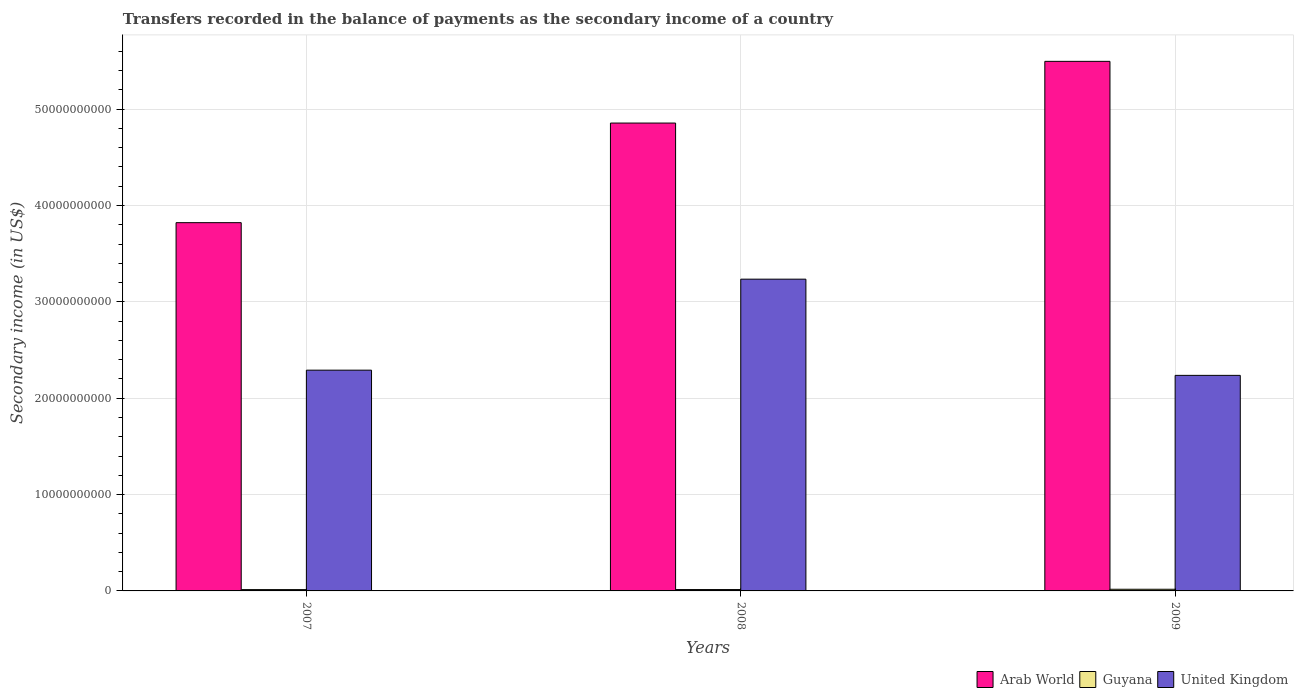How many different coloured bars are there?
Keep it short and to the point. 3. How many groups of bars are there?
Ensure brevity in your answer.  3. Are the number of bars per tick equal to the number of legend labels?
Your answer should be very brief. Yes. Are the number of bars on each tick of the X-axis equal?
Ensure brevity in your answer.  Yes. What is the secondary income of in Guyana in 2008?
Your answer should be very brief. 1.41e+08. Across all years, what is the maximum secondary income of in Guyana?
Provide a succinct answer. 1.72e+08. Across all years, what is the minimum secondary income of in Guyana?
Keep it short and to the point. 1.37e+08. In which year was the secondary income of in Arab World maximum?
Keep it short and to the point. 2009. What is the total secondary income of in Arab World in the graph?
Provide a short and direct response. 1.42e+11. What is the difference between the secondary income of in Arab World in 2007 and that in 2008?
Offer a very short reply. -1.03e+1. What is the difference between the secondary income of in Arab World in 2007 and the secondary income of in United Kingdom in 2009?
Offer a terse response. 1.58e+1. What is the average secondary income of in United Kingdom per year?
Ensure brevity in your answer.  2.59e+1. In the year 2009, what is the difference between the secondary income of in United Kingdom and secondary income of in Guyana?
Provide a succinct answer. 2.22e+1. What is the ratio of the secondary income of in United Kingdom in 2007 to that in 2009?
Offer a very short reply. 1.02. Is the difference between the secondary income of in United Kingdom in 2008 and 2009 greater than the difference between the secondary income of in Guyana in 2008 and 2009?
Provide a succinct answer. Yes. What is the difference between the highest and the second highest secondary income of in Guyana?
Provide a short and direct response. 3.10e+07. What is the difference between the highest and the lowest secondary income of in United Kingdom?
Provide a succinct answer. 9.98e+09. What does the 2nd bar from the left in 2009 represents?
Give a very brief answer. Guyana. What does the 2nd bar from the right in 2008 represents?
Keep it short and to the point. Guyana. Is it the case that in every year, the sum of the secondary income of in United Kingdom and secondary income of in Arab World is greater than the secondary income of in Guyana?
Your answer should be very brief. Yes. How many bars are there?
Provide a short and direct response. 9. Are all the bars in the graph horizontal?
Your answer should be very brief. No. What is the difference between two consecutive major ticks on the Y-axis?
Keep it short and to the point. 1.00e+1. Does the graph contain grids?
Ensure brevity in your answer.  Yes. How are the legend labels stacked?
Offer a terse response. Horizontal. What is the title of the graph?
Ensure brevity in your answer.  Transfers recorded in the balance of payments as the secondary income of a country. What is the label or title of the X-axis?
Your response must be concise. Years. What is the label or title of the Y-axis?
Your answer should be very brief. Secondary income (in US$). What is the Secondary income (in US$) of Arab World in 2007?
Ensure brevity in your answer.  3.82e+1. What is the Secondary income (in US$) of Guyana in 2007?
Give a very brief answer. 1.37e+08. What is the Secondary income (in US$) of United Kingdom in 2007?
Your response must be concise. 2.29e+1. What is the Secondary income (in US$) of Arab World in 2008?
Make the answer very short. 4.86e+1. What is the Secondary income (in US$) in Guyana in 2008?
Provide a short and direct response. 1.41e+08. What is the Secondary income (in US$) of United Kingdom in 2008?
Make the answer very short. 3.24e+1. What is the Secondary income (in US$) in Arab World in 2009?
Make the answer very short. 5.50e+1. What is the Secondary income (in US$) in Guyana in 2009?
Offer a terse response. 1.72e+08. What is the Secondary income (in US$) of United Kingdom in 2009?
Your answer should be compact. 2.24e+1. Across all years, what is the maximum Secondary income (in US$) of Arab World?
Provide a succinct answer. 5.50e+1. Across all years, what is the maximum Secondary income (in US$) of Guyana?
Give a very brief answer. 1.72e+08. Across all years, what is the maximum Secondary income (in US$) in United Kingdom?
Make the answer very short. 3.24e+1. Across all years, what is the minimum Secondary income (in US$) of Arab World?
Your answer should be very brief. 3.82e+1. Across all years, what is the minimum Secondary income (in US$) of Guyana?
Your response must be concise. 1.37e+08. Across all years, what is the minimum Secondary income (in US$) in United Kingdom?
Your answer should be very brief. 2.24e+1. What is the total Secondary income (in US$) in Arab World in the graph?
Ensure brevity in your answer.  1.42e+11. What is the total Secondary income (in US$) in Guyana in the graph?
Offer a terse response. 4.50e+08. What is the total Secondary income (in US$) in United Kingdom in the graph?
Make the answer very short. 7.76e+1. What is the difference between the Secondary income (in US$) of Arab World in 2007 and that in 2008?
Ensure brevity in your answer.  -1.03e+1. What is the difference between the Secondary income (in US$) of Guyana in 2007 and that in 2008?
Keep it short and to the point. -4.12e+06. What is the difference between the Secondary income (in US$) in United Kingdom in 2007 and that in 2008?
Offer a terse response. -9.44e+09. What is the difference between the Secondary income (in US$) of Arab World in 2007 and that in 2009?
Provide a succinct answer. -1.67e+1. What is the difference between the Secondary income (in US$) in Guyana in 2007 and that in 2009?
Make the answer very short. -3.51e+07. What is the difference between the Secondary income (in US$) of United Kingdom in 2007 and that in 2009?
Offer a very short reply. 5.41e+08. What is the difference between the Secondary income (in US$) of Arab World in 2008 and that in 2009?
Your response must be concise. -6.40e+09. What is the difference between the Secondary income (in US$) in Guyana in 2008 and that in 2009?
Keep it short and to the point. -3.10e+07. What is the difference between the Secondary income (in US$) of United Kingdom in 2008 and that in 2009?
Make the answer very short. 9.98e+09. What is the difference between the Secondary income (in US$) in Arab World in 2007 and the Secondary income (in US$) in Guyana in 2008?
Provide a succinct answer. 3.81e+1. What is the difference between the Secondary income (in US$) in Arab World in 2007 and the Secondary income (in US$) in United Kingdom in 2008?
Make the answer very short. 5.86e+09. What is the difference between the Secondary income (in US$) in Guyana in 2007 and the Secondary income (in US$) in United Kingdom in 2008?
Offer a very short reply. -3.22e+1. What is the difference between the Secondary income (in US$) in Arab World in 2007 and the Secondary income (in US$) in Guyana in 2009?
Offer a terse response. 3.80e+1. What is the difference between the Secondary income (in US$) of Arab World in 2007 and the Secondary income (in US$) of United Kingdom in 2009?
Give a very brief answer. 1.58e+1. What is the difference between the Secondary income (in US$) of Guyana in 2007 and the Secondary income (in US$) of United Kingdom in 2009?
Keep it short and to the point. -2.22e+1. What is the difference between the Secondary income (in US$) in Arab World in 2008 and the Secondary income (in US$) in Guyana in 2009?
Provide a succinct answer. 4.84e+1. What is the difference between the Secondary income (in US$) in Arab World in 2008 and the Secondary income (in US$) in United Kingdom in 2009?
Your answer should be very brief. 2.62e+1. What is the difference between the Secondary income (in US$) in Guyana in 2008 and the Secondary income (in US$) in United Kingdom in 2009?
Give a very brief answer. -2.22e+1. What is the average Secondary income (in US$) in Arab World per year?
Ensure brevity in your answer.  4.72e+1. What is the average Secondary income (in US$) of Guyana per year?
Your answer should be very brief. 1.50e+08. What is the average Secondary income (in US$) of United Kingdom per year?
Your answer should be compact. 2.59e+1. In the year 2007, what is the difference between the Secondary income (in US$) of Arab World and Secondary income (in US$) of Guyana?
Ensure brevity in your answer.  3.81e+1. In the year 2007, what is the difference between the Secondary income (in US$) in Arab World and Secondary income (in US$) in United Kingdom?
Offer a terse response. 1.53e+1. In the year 2007, what is the difference between the Secondary income (in US$) in Guyana and Secondary income (in US$) in United Kingdom?
Keep it short and to the point. -2.28e+1. In the year 2008, what is the difference between the Secondary income (in US$) in Arab World and Secondary income (in US$) in Guyana?
Provide a short and direct response. 4.84e+1. In the year 2008, what is the difference between the Secondary income (in US$) in Arab World and Secondary income (in US$) in United Kingdom?
Offer a terse response. 1.62e+1. In the year 2008, what is the difference between the Secondary income (in US$) of Guyana and Secondary income (in US$) of United Kingdom?
Ensure brevity in your answer.  -3.22e+1. In the year 2009, what is the difference between the Secondary income (in US$) of Arab World and Secondary income (in US$) of Guyana?
Provide a short and direct response. 5.48e+1. In the year 2009, what is the difference between the Secondary income (in US$) of Arab World and Secondary income (in US$) of United Kingdom?
Offer a terse response. 3.26e+1. In the year 2009, what is the difference between the Secondary income (in US$) in Guyana and Secondary income (in US$) in United Kingdom?
Make the answer very short. -2.22e+1. What is the ratio of the Secondary income (in US$) of Arab World in 2007 to that in 2008?
Offer a very short reply. 0.79. What is the ratio of the Secondary income (in US$) of Guyana in 2007 to that in 2008?
Provide a short and direct response. 0.97. What is the ratio of the Secondary income (in US$) of United Kingdom in 2007 to that in 2008?
Provide a short and direct response. 0.71. What is the ratio of the Secondary income (in US$) in Arab World in 2007 to that in 2009?
Your answer should be very brief. 0.7. What is the ratio of the Secondary income (in US$) in Guyana in 2007 to that in 2009?
Provide a succinct answer. 0.8. What is the ratio of the Secondary income (in US$) in United Kingdom in 2007 to that in 2009?
Make the answer very short. 1.02. What is the ratio of the Secondary income (in US$) in Arab World in 2008 to that in 2009?
Give a very brief answer. 0.88. What is the ratio of the Secondary income (in US$) of Guyana in 2008 to that in 2009?
Your response must be concise. 0.82. What is the ratio of the Secondary income (in US$) of United Kingdom in 2008 to that in 2009?
Your response must be concise. 1.45. What is the difference between the highest and the second highest Secondary income (in US$) in Arab World?
Provide a succinct answer. 6.40e+09. What is the difference between the highest and the second highest Secondary income (in US$) in Guyana?
Provide a succinct answer. 3.10e+07. What is the difference between the highest and the second highest Secondary income (in US$) of United Kingdom?
Make the answer very short. 9.44e+09. What is the difference between the highest and the lowest Secondary income (in US$) of Arab World?
Your response must be concise. 1.67e+1. What is the difference between the highest and the lowest Secondary income (in US$) in Guyana?
Offer a terse response. 3.51e+07. What is the difference between the highest and the lowest Secondary income (in US$) in United Kingdom?
Offer a terse response. 9.98e+09. 